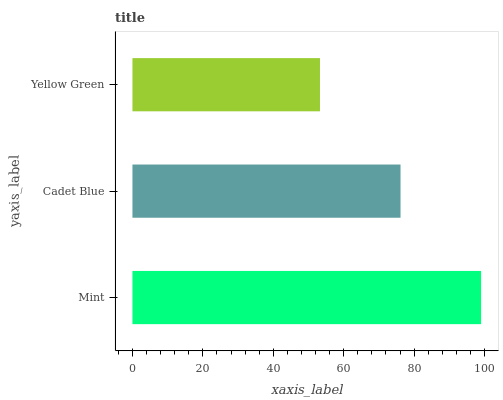Is Yellow Green the minimum?
Answer yes or no. Yes. Is Mint the maximum?
Answer yes or no. Yes. Is Cadet Blue the minimum?
Answer yes or no. No. Is Cadet Blue the maximum?
Answer yes or no. No. Is Mint greater than Cadet Blue?
Answer yes or no. Yes. Is Cadet Blue less than Mint?
Answer yes or no. Yes. Is Cadet Blue greater than Mint?
Answer yes or no. No. Is Mint less than Cadet Blue?
Answer yes or no. No. Is Cadet Blue the high median?
Answer yes or no. Yes. Is Cadet Blue the low median?
Answer yes or no. Yes. Is Mint the high median?
Answer yes or no. No. Is Mint the low median?
Answer yes or no. No. 